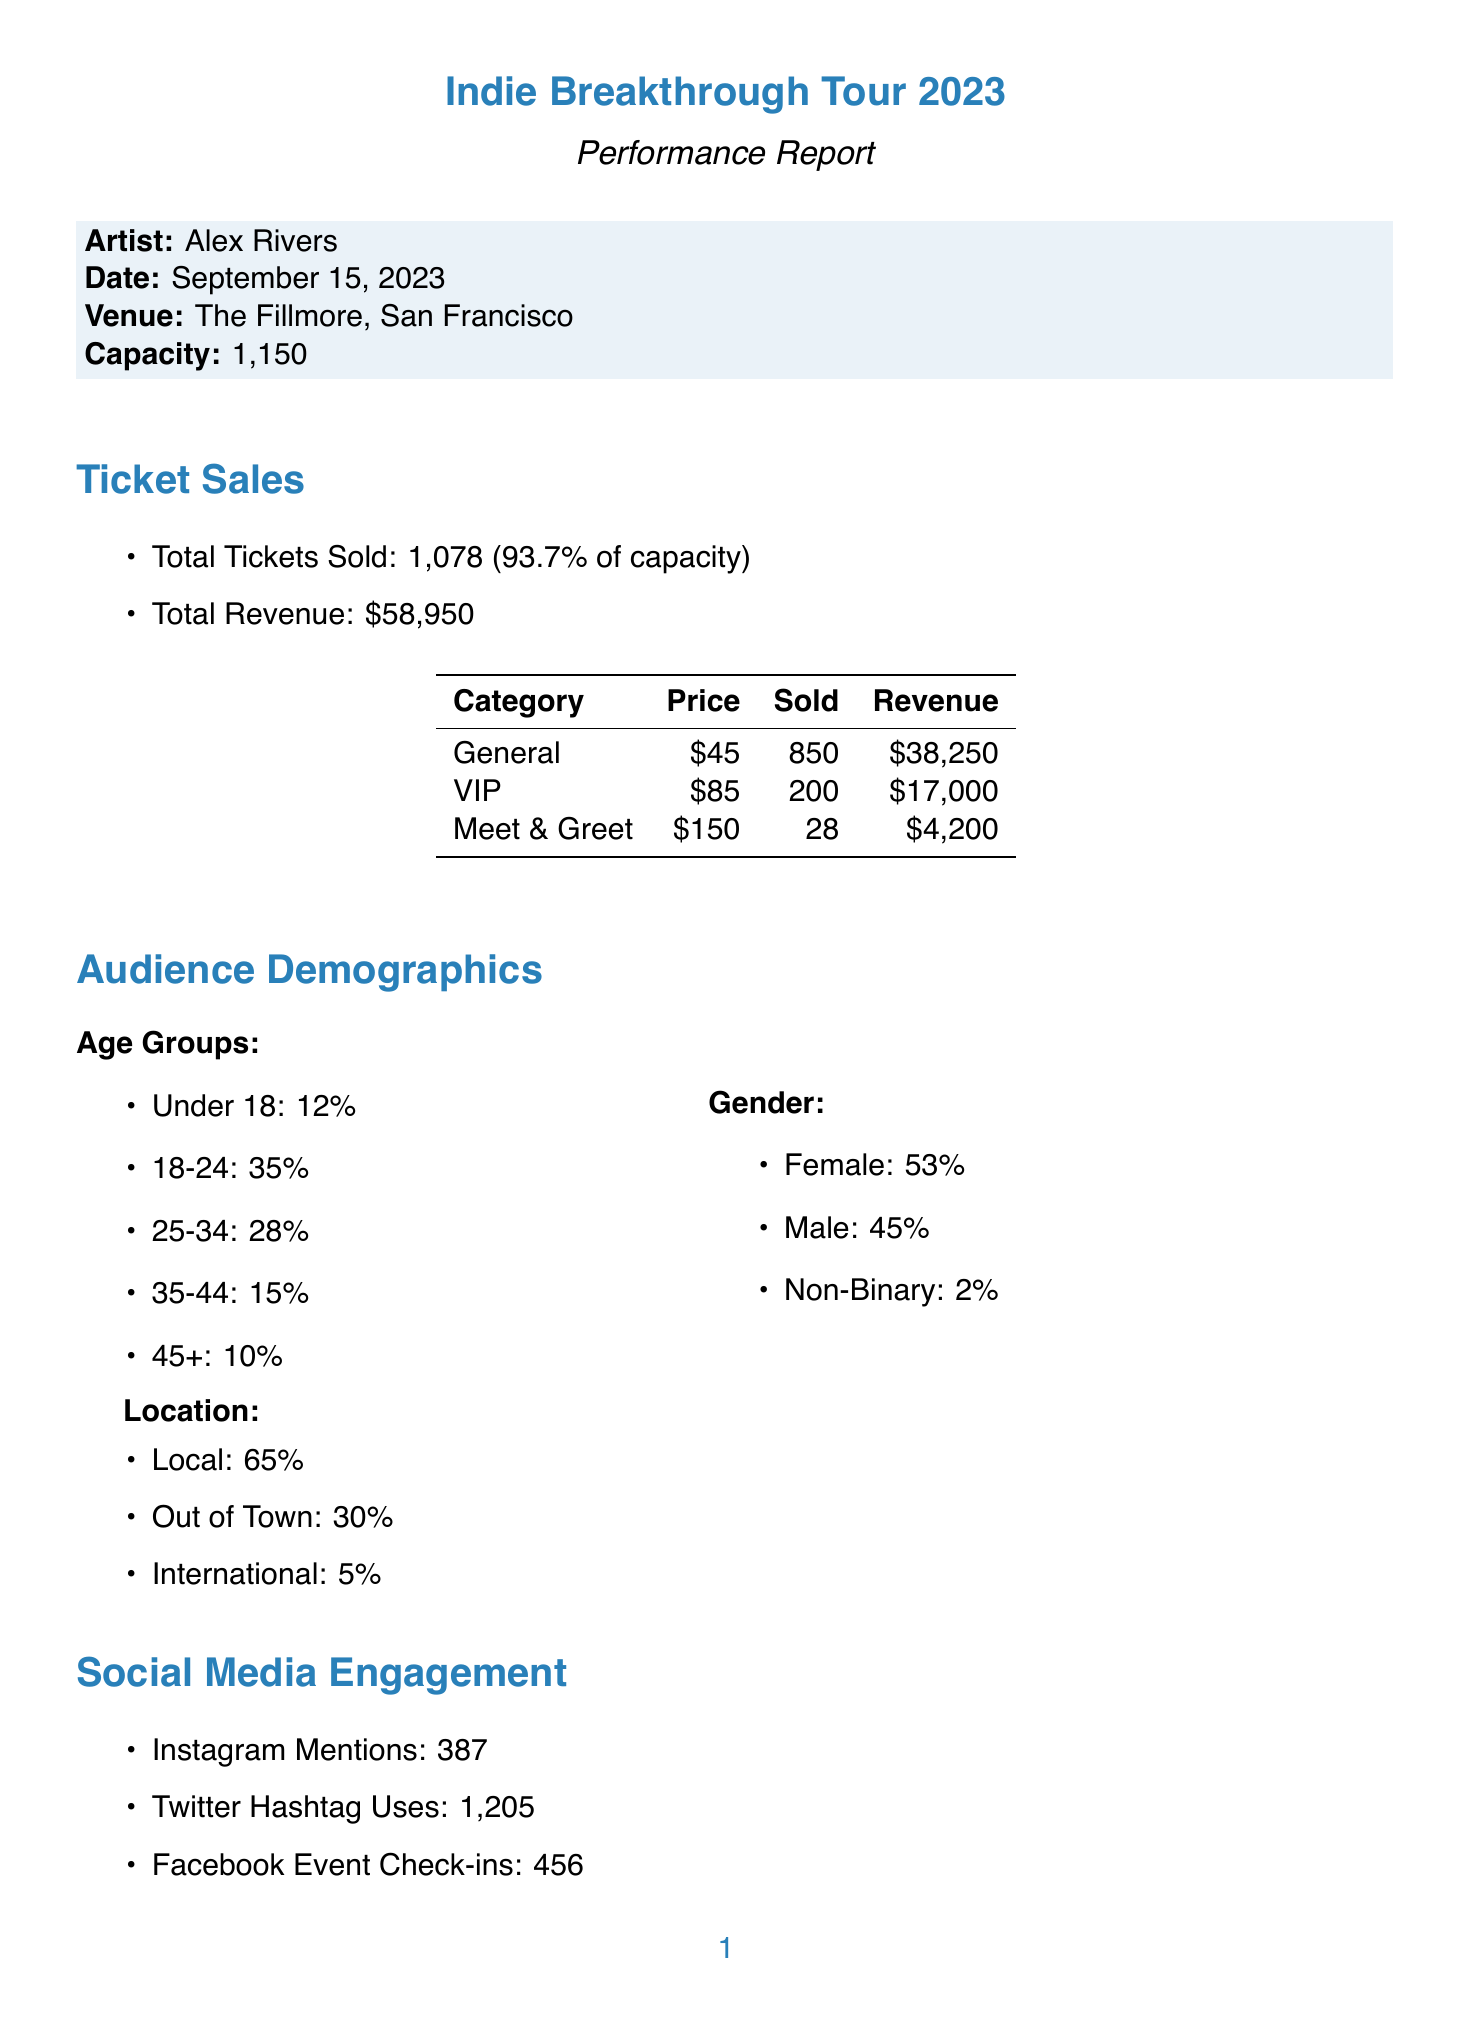what was the date of the performance? The date of the performance is explicitly stated in the document as September 15, 2023.
Answer: September 15, 2023 what is the total number of tickets sold? The total tickets sold is provided in the ticket sales section, which states 1,078 tickets were sold.
Answer: 1,078 what is the capacity of The Fillmore venue? The capacity of the venue is mentioned as 1,150 in the document.
Answer: 1,150 what percentage of venue capacity was filled? The percentage capacity filled is indicated in the ticket sales section as 93.7%.
Answer: 93.7% how much revenue was generated from merchandise sales? The total revenue from merchandise sales is stated as $8,750 in the document.
Answer: $8,750 which age group has the highest attendance percentage? The age group with the highest percentage is 18-24, which has 35% attendance according to the demographics section.
Answer: 18-24 what was the average feedback rating for the performance? The average rating for the performance is explicitly mentioned as 4.8 out of 5 in the performance feedback section.
Answer: 4.8 how many units of the Tour T-Shirt were sold? The number of Tour T-Shirts sold is provided in the merchandise sales table as 150 units.
Answer: 150 which social media channel was the most effective for marketing? The most effective marketing channel is social media, which has an effectiveness percentage of 45%.
Answer: Social Media 